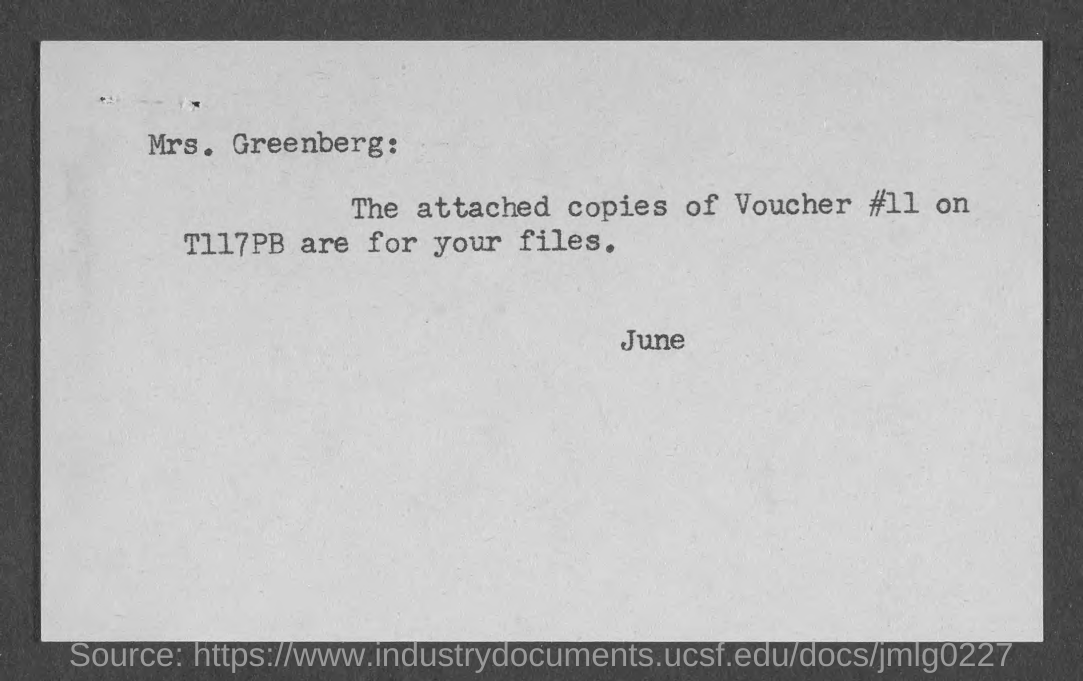List a handful of essential elements in this visual. The addressee of this document is Mrs. Greenberg. The sender of this document is June... The voucher number provided in the document is Voucher #11. 